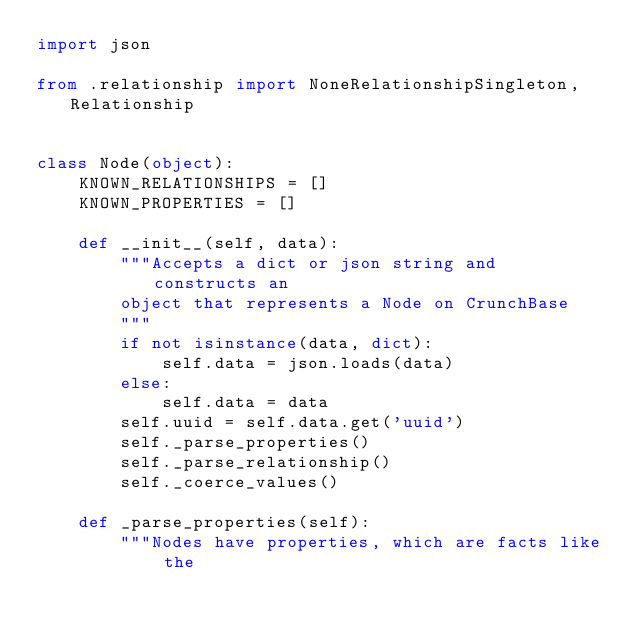<code> <loc_0><loc_0><loc_500><loc_500><_Python_>import json

from .relationship import NoneRelationshipSingleton, Relationship


class Node(object):
    KNOWN_RELATIONSHIPS = []
    KNOWN_PROPERTIES = []

    def __init__(self, data):
        """Accepts a dict or json string and constructs an
        object that represents a Node on CrunchBase
        """
        if not isinstance(data, dict):
            self.data = json.loads(data)
        else:
            self.data = data
        self.uuid = self.data.get('uuid')
        self._parse_properties()
        self._parse_relationship()
        self._coerce_values()

    def _parse_properties(self):
        """Nodes have properties, which are facts like the</code> 